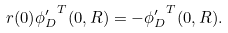<formula> <loc_0><loc_0><loc_500><loc_500>r ( 0 ) { \phi ^ { \prime } _ { D } } ^ { T } ( 0 , R ) = - { \phi ^ { \prime } _ { D } } ^ { T } ( 0 , R ) .</formula> 